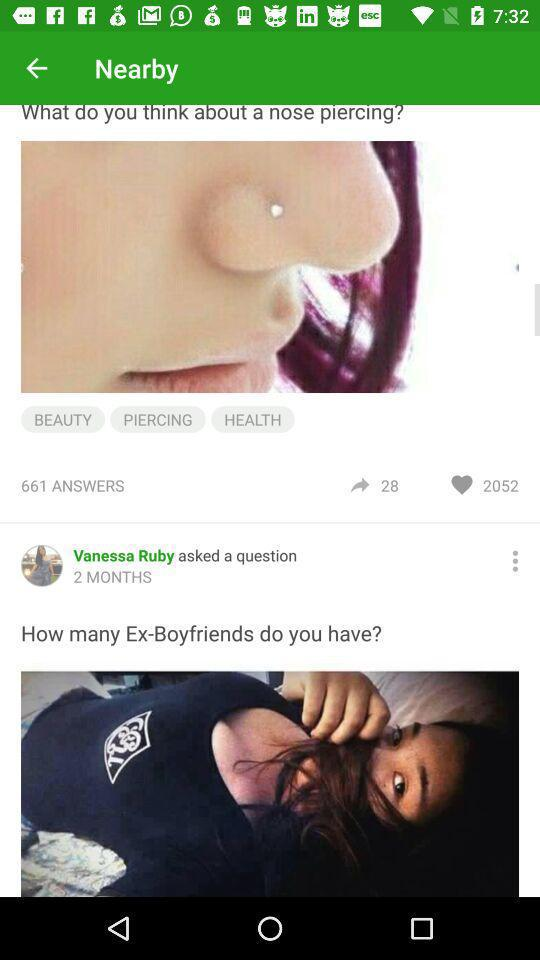How many answers are there to the question "What do you think about a nose piercing?"? There are 661 answers to the question. 